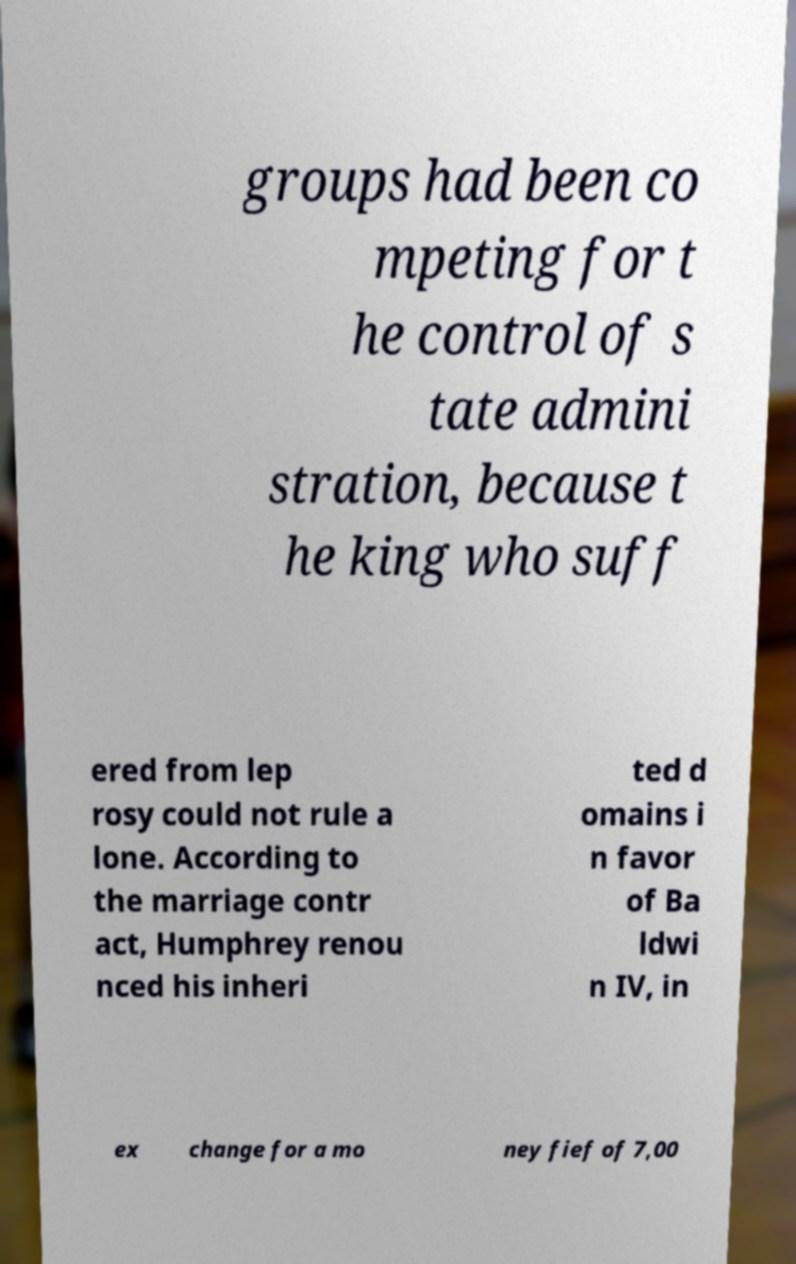There's text embedded in this image that I need extracted. Can you transcribe it verbatim? groups had been co mpeting for t he control of s tate admini stration, because t he king who suff ered from lep rosy could not rule a lone. According to the marriage contr act, Humphrey renou nced his inheri ted d omains i n favor of Ba ldwi n IV, in ex change for a mo ney fief of 7,00 